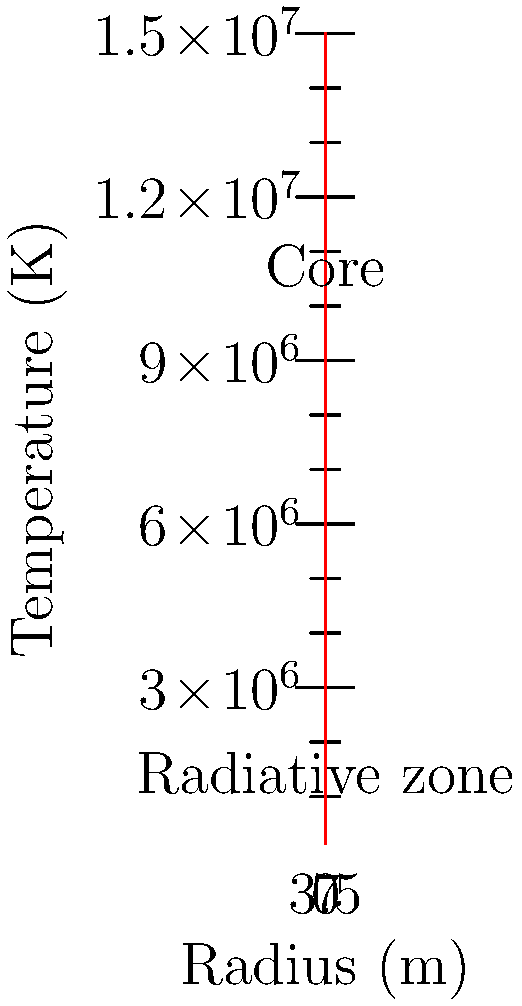In a fusion reactor inspired by the sun's core, as depicted in South Asian mythology, the temperature profile is given by $T(r) = 15 \times 10^6 e^{-r/1.5}$ K, where $r$ is the radius in meters. Calculate the temperature gradient $\frac{dT}{dr}$ at $r = 3$ m. To find the temperature gradient, we need to follow these steps:

1) The temperature profile is given by:
   $T(r) = 15 \times 10^6 e^{-r/1.5}$ K

2) To find the gradient, we need to differentiate T(r) with respect to r:
   $\frac{dT}{dr} = \frac{d}{dr}(15 \times 10^6 e^{-r/1.5})$

3) Using the chain rule:
   $\frac{dT}{dr} = 15 \times 10^6 \cdot \frac{d}{dr}(e^{-r/1.5})$

4) The derivative of $e^x$ is $e^x$, so:
   $\frac{dT}{dr} = 15 \times 10^6 \cdot (-\frac{1}{1.5}) \cdot e^{-r/1.5}$

5) Simplifying:
   $\frac{dT}{dr} = -10 \times 10^6 \cdot e^{-r/1.5}$ K/m

6) Now, we evaluate this at r = 3 m:
   $\frac{dT}{dr}|_{r=3} = -10 \times 10^6 \cdot e^{-3/1.5}$ K/m

7) Calculate:
   $\frac{dT}{dr}|_{r=3} = -10 \times 10^6 \cdot e^{-2}$ K/m
   $= -10 \times 10^6 \cdot 0.1353$ K/m
   $= -1.353 \times 10^6$ K/m

Thus, the temperature gradient at r = 3 m is -1.353 × 10^6 K/m.
Answer: -1.353 × 10^6 K/m 